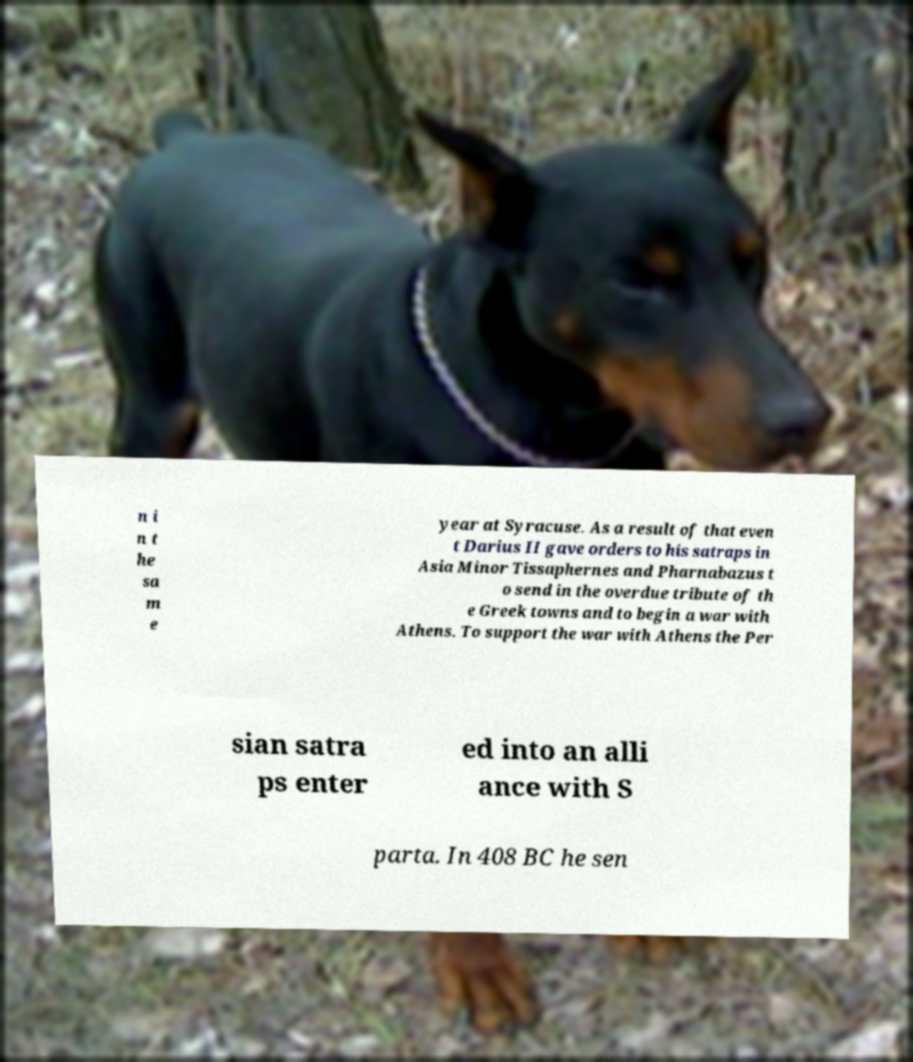What messages or text are displayed in this image? I need them in a readable, typed format. n i n t he sa m e year at Syracuse. As a result of that even t Darius II gave orders to his satraps in Asia Minor Tissaphernes and Pharnabazus t o send in the overdue tribute of th e Greek towns and to begin a war with Athens. To support the war with Athens the Per sian satra ps enter ed into an alli ance with S parta. In 408 BC he sen 